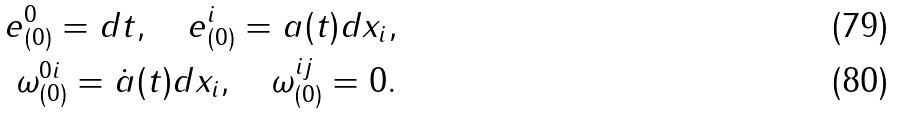Convert formula to latex. <formula><loc_0><loc_0><loc_500><loc_500>e ^ { 0 } _ { ( 0 ) } = d t , \quad e ^ { i } _ { ( 0 ) } = a ( t ) d x _ { i } , \\ \omega ^ { 0 i } _ { ( 0 ) } = { \dot { a } ( t ) } d x _ { i } , \quad \omega ^ { i j } _ { ( 0 ) } = 0 .</formula> 